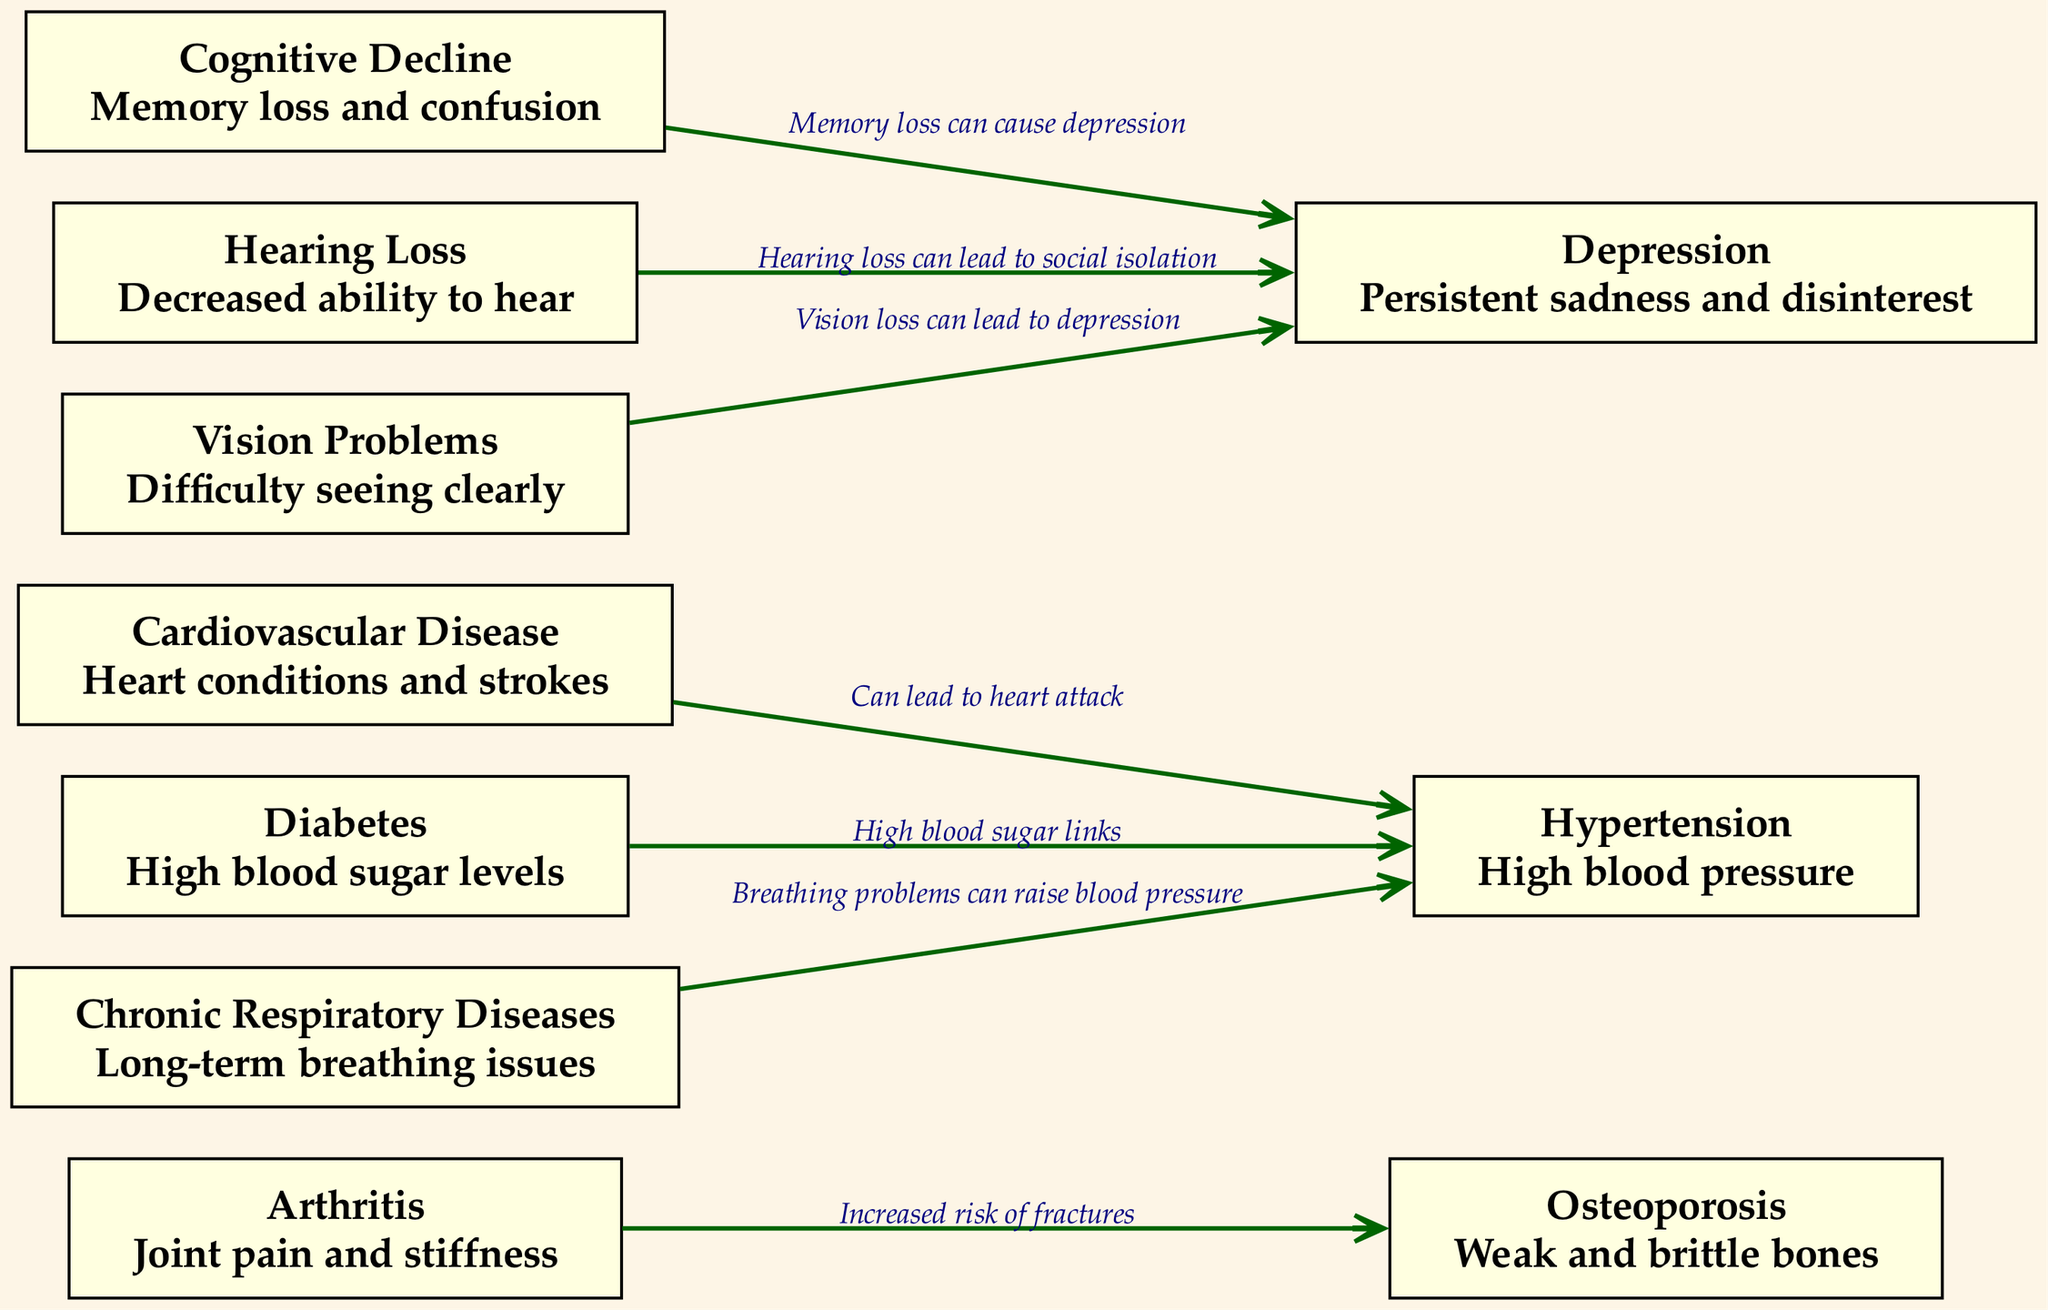What are the two main symptoms of Arthritis? According to the diagram, Arthritis is associated with "Joint pain and stiffness" as its symptoms. These two phrases are directly written in the description of the Arthritis node in the diagram.
Answer: Joint pain and stiffness How many nodes are present in this diagram? The diagram has a total of 10 nodes, each representing a different health condition or related information. This can be counted directly from the nodes section of the provided data.
Answer: 10 What relationship does Diabetic condition have with Hypertension? In the diagram, Diabetes is linked to Hypertension with the relationship specified as "High blood sugar links." This relationship can be found between the respective nodes in the diagram.
Answer: High blood sugar links Which health condition is associated with persistent sadness? The diagram indicates that Depression is associated with "Persistent sadness and disinterest." This information derives from the description of the Depression node.
Answer: Depression What health condition is connected to memory loss? The diagram shows that Cognitive Decline leads to Depression, where the relationship is described as "Memory loss can cause depression." This connection illustrates the impact of cognitive decline on emotional well-being.
Answer: Cognitive Decline How does Hearing Loss relate to Depression? The relationship between Hearing Loss and Depression is described as "Hearing loss can lead to social isolation." This suggests that the inability to hear may affect social interactions, contributing to feelings of depression.
Answer: Hearing loss can lead to social isolation If one has chronic respiratory diseases, what risk do they face concerning blood pressure? The diagram states that Chronic Respiratory Diseases can lead to Hypertension, where the relationship is noted as "Breathing problems can raise blood pressure." Therefore, the presence of chronic respiratory diseases could heighten blood pressure levels.
Answer: Breathing problems can raise blood pressure What is the relationship between Cardiovascular Disease and Hypertension? Cardiovascular Disease is linked to Hypertension with the relationship "Can lead to heart attack." This implies that hypertension may be a consequence or contributor to heart-related issues depicted for this condition.
Answer: Can lead to heart attack What type of symptoms does Osteoporosis present? Osteoporosis is described in the diagram as having the symptom "Weak and brittle bones." This is a direct description of the health condition found at the respective node.
Answer: Weak and brittle bones 